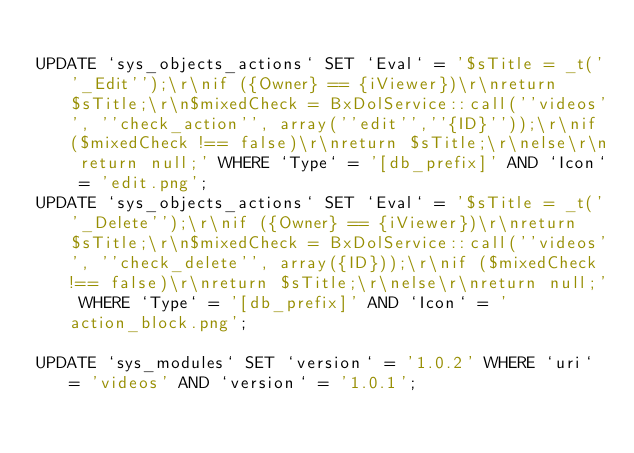Convert code to text. <code><loc_0><loc_0><loc_500><loc_500><_SQL_>
UPDATE `sys_objects_actions` SET `Eval` = '$sTitle = _t(''_Edit'');\r\nif ({Owner} == {iViewer})\r\nreturn $sTitle;\r\n$mixedCheck = BxDolService::call(''videos'', ''check_action'', array(''edit'',''{ID}''));\r\nif ($mixedCheck !== false)\r\nreturn $sTitle;\r\nelse\r\n return null;' WHERE `Type` = '[db_prefix]' AND `Icon` = 'edit.png';
UPDATE `sys_objects_actions` SET `Eval` = '$sTitle = _t(''_Delete'');\r\nif ({Owner} == {iViewer})\r\nreturn $sTitle;\r\n$mixedCheck = BxDolService::call(''videos'', ''check_delete'', array({ID}));\r\nif ($mixedCheck !== false)\r\nreturn $sTitle;\r\nelse\r\nreturn null;' WHERE `Type` = '[db_prefix]' AND `Icon` = 'action_block.png';

UPDATE `sys_modules` SET `version` = '1.0.2' WHERE `uri` = 'videos' AND `version` = '1.0.1';

</code> 